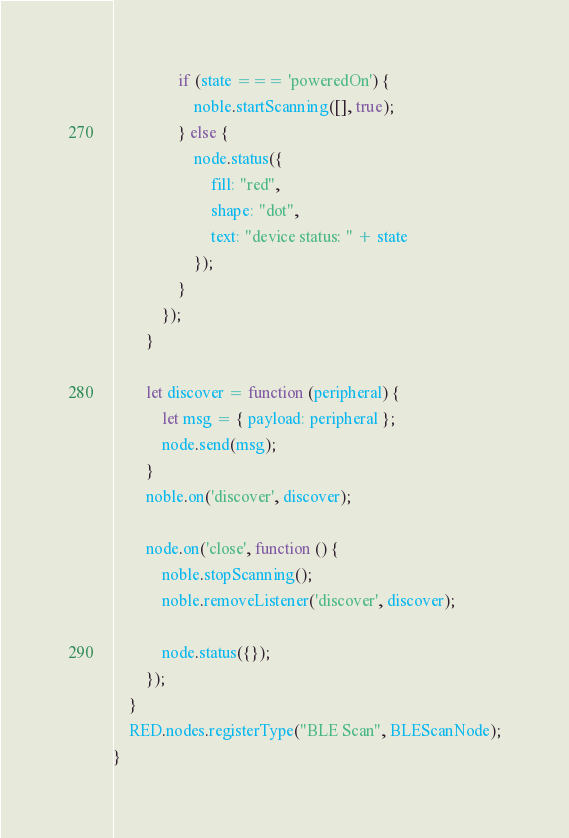<code> <loc_0><loc_0><loc_500><loc_500><_JavaScript_>                if (state === 'poweredOn') {
                    noble.startScanning([], true);
                } else {
                    node.status({
                        fill: "red",
                        shape: "dot",
                        text: "device status: " + state
                    });
                }
            });
        }

        let discover = function (peripheral) {
            let msg = { payload: peripheral };
            node.send(msg);
        }
        noble.on('discover', discover);

        node.on('close', function () {
            noble.stopScanning();
            noble.removeListener('discover', discover);

            node.status({});
        });
    }
    RED.nodes.registerType("BLE Scan", BLEScanNode);
}
</code> 